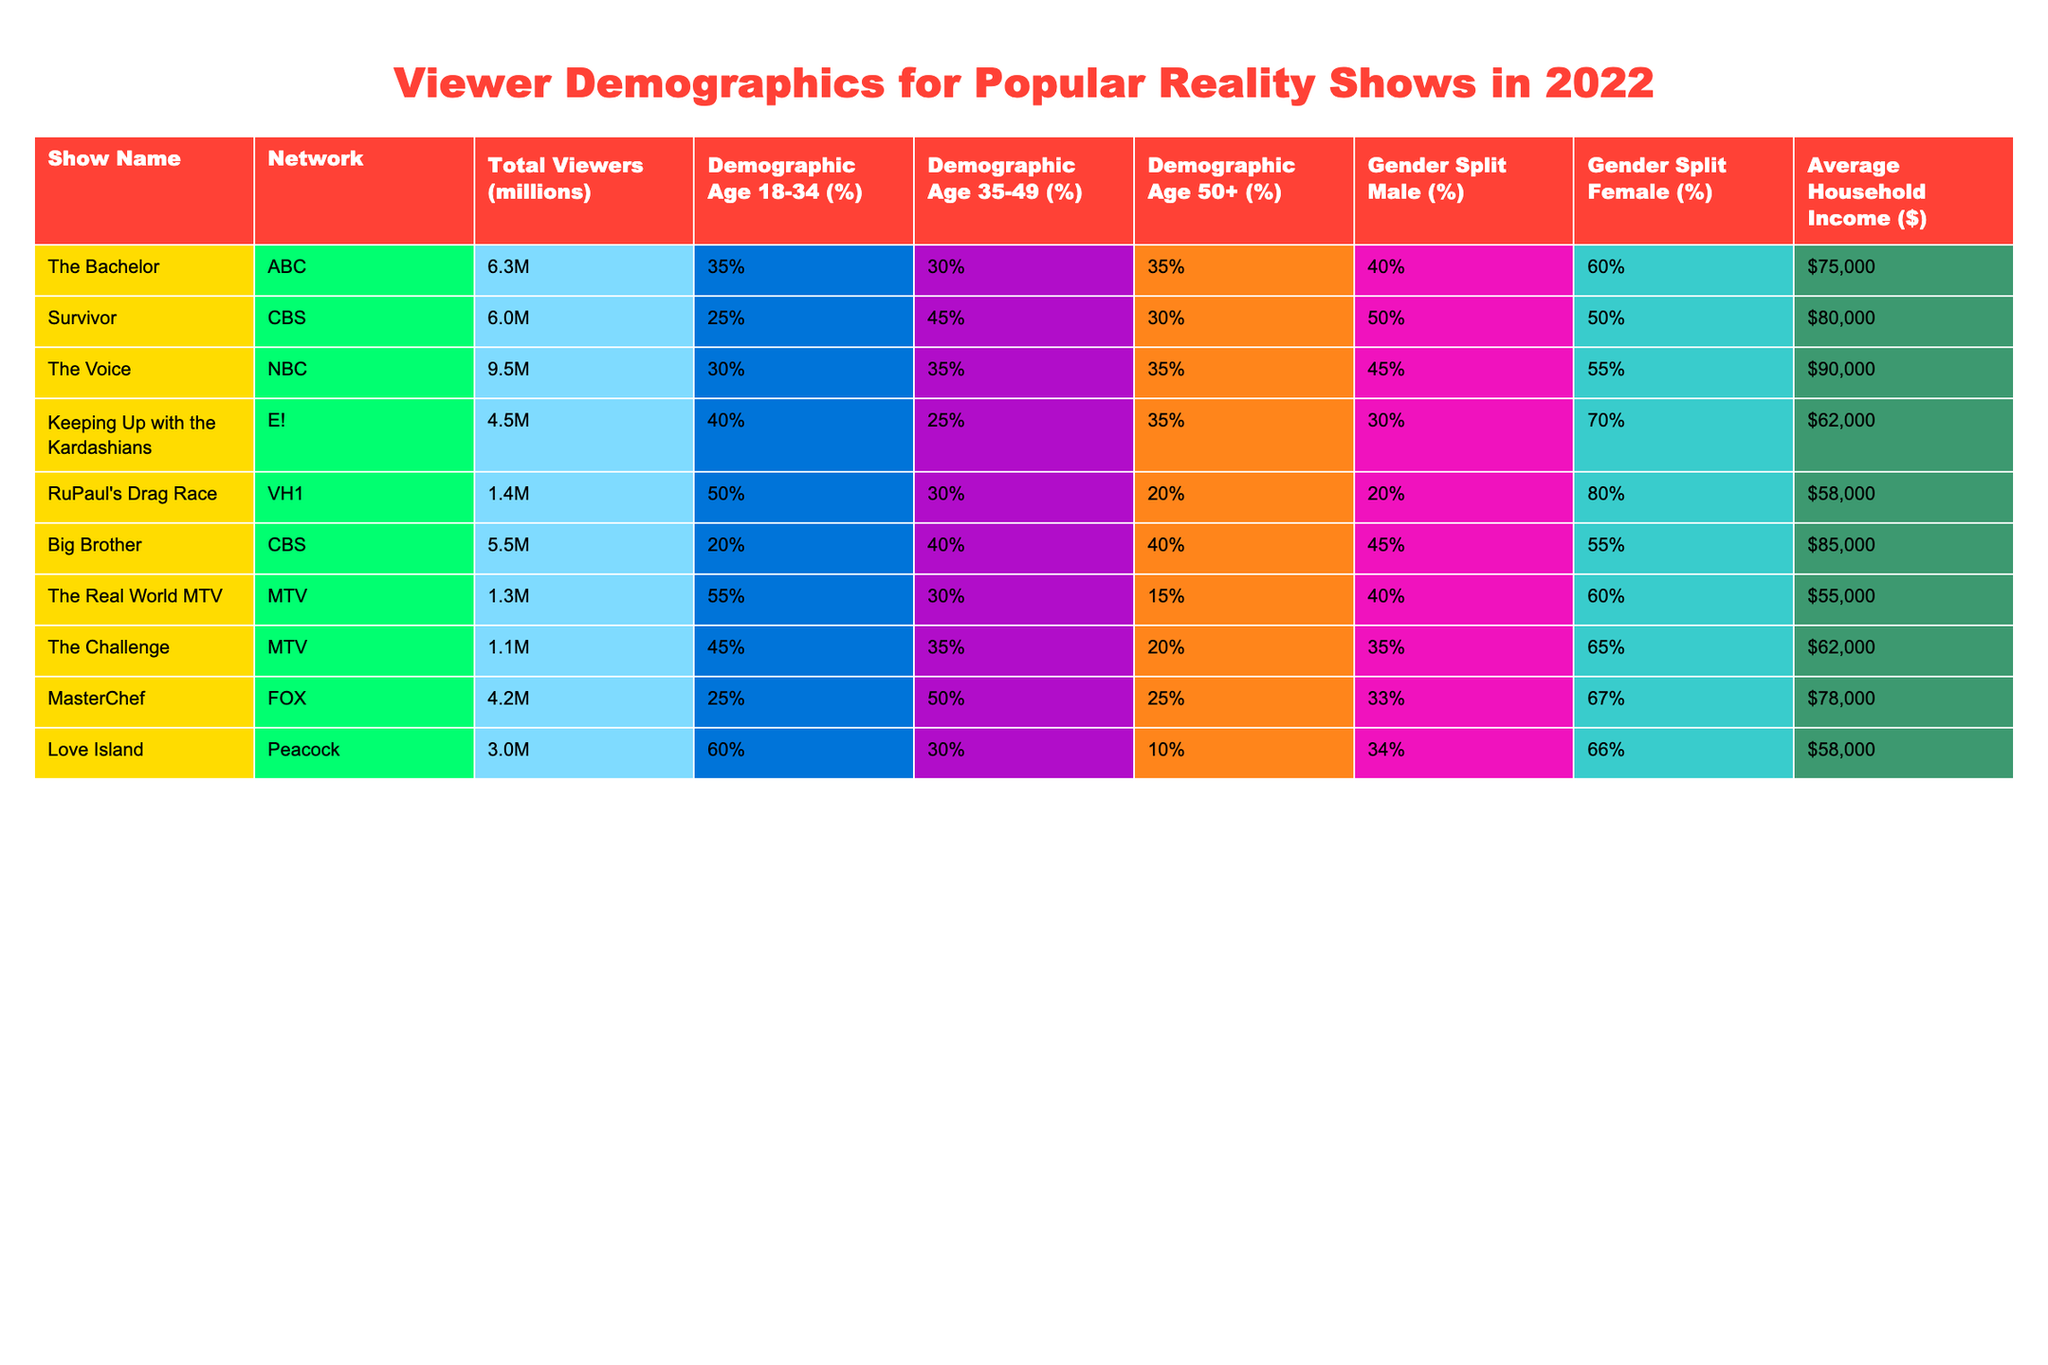What is the total number of viewers for 'The Voice'? The table indicates that 'The Voice' has a total viewership of 9.5 million.
Answer: 9.5 million Which show has the highest percentage of viewers aged 18-34? The table shows that 'Love Island' has the highest percentage of viewers aged 18-34 at 60%.
Answer: 60% What is the average household income for 'Keeping Up with the Kardashians'? The table states that the average household income for 'Keeping Up with the Kardashians' is $62,000.
Answer: $62,000 Is the gender split for 'The Bachelor' more female than male? The table shows a gender split of 60% female and 40% male, indicating that yes, it is more female than male.
Answer: Yes Which show has the lowest total viewers and what is that number? The table indicates that 'RuPaul's Drag Race' has the lowest total viewers at 1.4 million.
Answer: 1.4 million What percentage of viewers aged 35-49 watch 'Big Brother'? According to the table, 40% of the viewers for 'Big Brother' are aged 35-49.
Answer: 40% By how much does the average household income of 'Survivor' exceed that of 'RuPaul's Drag Race'? 'Survivor' has an average household income of $80,000, while 'RuPaul's Drag Race' has $58,000. The difference is $80,000 - $58,000 = $22,000.
Answer: $22,000 Which show has a gender split where females make up a majority? 'Keeping Up with the Kardashians' has a gender split of 70% female, which is a majority.
Answer: Keeping Up with the Kardashians What is the combined percentage of viewers aged 50+ for 'The Bachelor' and 'Big Brother'? 'The Bachelor' has 35% and 'Big Brother' has 40% of viewers aged 50+. Combined, this gives 35% + 40% = 75%.
Answer: 75% Does 'MasterChef' attract more male viewers compared to 'The Challenge'? 'MasterChef' has a 33% male viewer split while 'The Challenge' has 35%. Thus, 'The Challenge' attracts more male viewers.
Answer: No What is the median demographic age percentage for viewers aged 18-34 across all shows? After ordering the percentages for viewers aged 18-34: 20, 25, 30, 35, 40, 45, 50, 55, 60, the median is the average of the 5th and 6th values: (40 + 45) / 2 = 42.5%.
Answer: 42.5% 